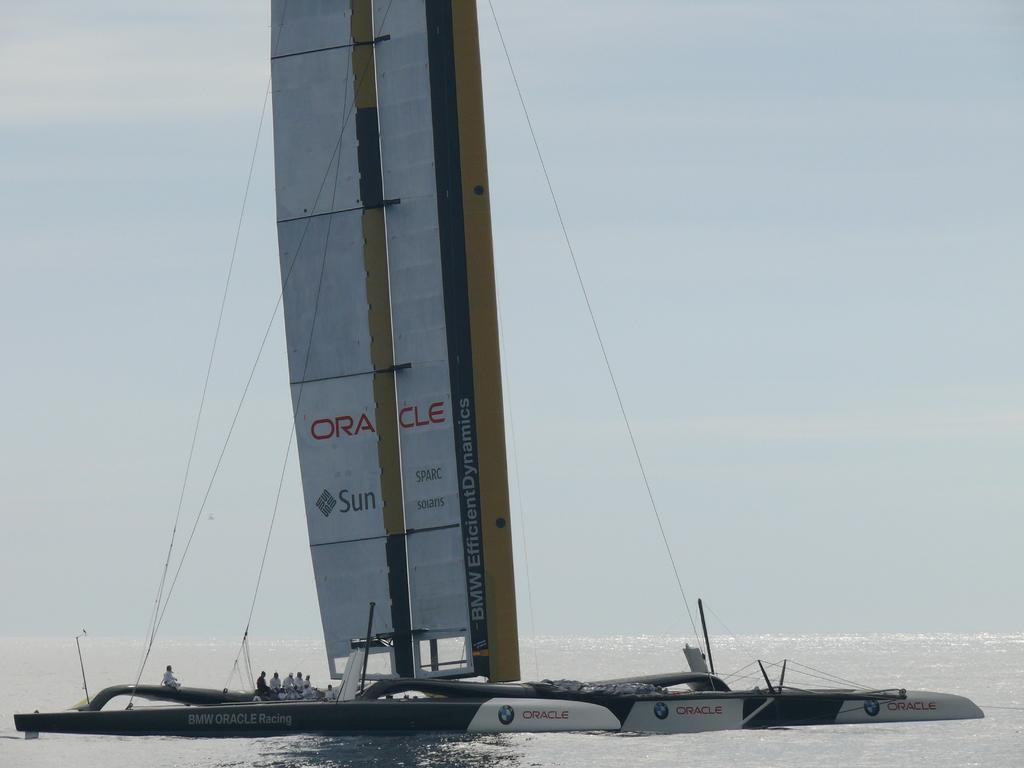What is the main subject of the image? The main subject of the image is a boat. Where is the boat located? The boat is on the water. Are there any people in the boat? Yes, there is a group of people in the boat. What can be seen in the background of the image? The sky in the background is white. What type of punishment is being handed out to the crayons in the image? There are no crayons present in the image, and therefore no punishment is being handed out. 